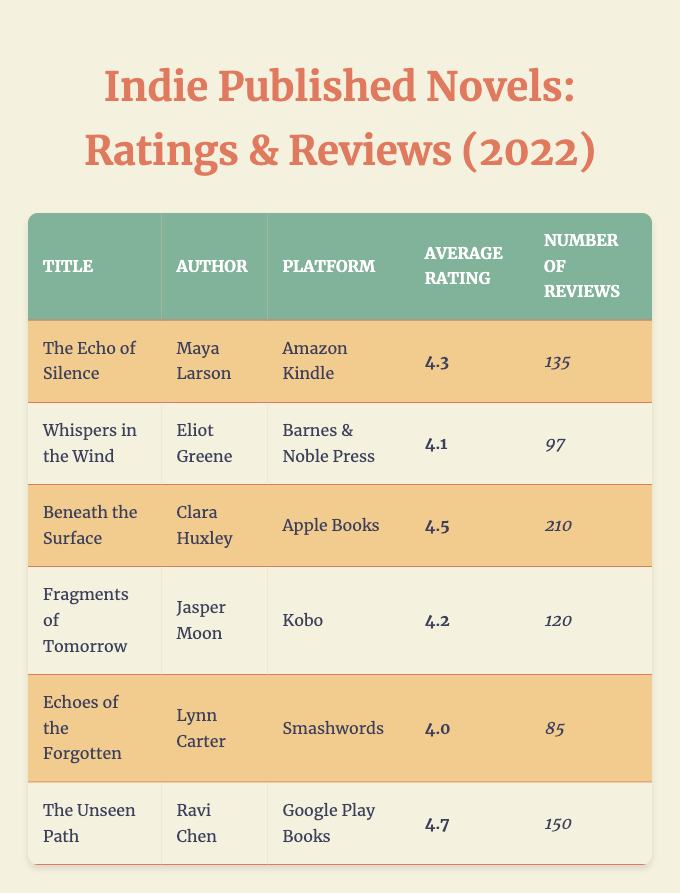What is the average rating of "Beneath the Surface"? The average rating of "Beneath the Surface" can be found in the "Average Rating" column next to its title. It is listed as 4.5.
Answer: 4.5 Which novel has the highest number of reviews? To determine which novel has the highest number of reviews, we can look at the "Number of Reviews" column. "Beneath the Surface" has the highest reviews at 210.
Answer: "Beneath the Surface" Is the average rating of "The Unseen Path" higher than 4.5? The average rating of "The Unseen Path" is 4.7, which is indeed higher than 4.5. Thus, the answer is yes.
Answer: Yes What is the total number of reviews for all novels listed? We can find the total number of reviews by adding the individual reviews from the "Number of Reviews" column: 135 + 97 + 210 + 120 + 85 + 150 = 897. Therefore, the total number of reviews is 897.
Answer: 897 Which platforms have indie novels with an average rating below 4.2? By checking the "Average Rating" column, the novels with ratings below 4.2 are "Echoes of the Forgotten" (4.0) and "Whispers in the Wind" (4.1). Therefore, the platforms are Smashwords and Barnes & Noble Press.
Answer: Smashwords and Barnes & Noble Press What is the average rating of novels published on Amazon Kindle and Google Play Books? The average rating for "The Echo of Silence" on Amazon Kindle is 4.3 and for "The Unseen Path" on Google Play Books is 4.7. The average of these two ratings is (4.3 + 4.7) / 2 = 4.5.
Answer: 4.5 Has any novel on Apple Books received fewer than 100 reviews? "Beneath the Surface," the only novel on Apple Books, has 210 reviews, which is more than 100. Therefore, the answer is no.
Answer: No Which author has the lowest-rated book? Looking at the "Average Rating" column, "Echoes of the Forgotten" by Lynn Carter is the lowest at 4.0.
Answer: Lynn Carter What is the difference in average ratings between the highest-rated and lowest-rated novels? The highest-rated novel is "The Unseen Path" with an average rating of 4.7, and the lowest-rated is "Echoes of the Forgotten" with a rating of 4.0. The difference is 4.7 - 4.0 = 0.7.
Answer: 0.7 